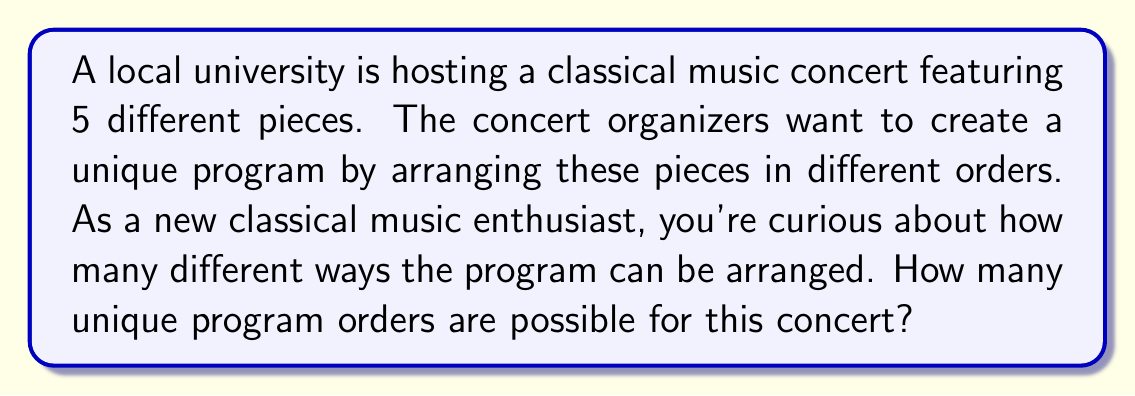Could you help me with this problem? To solve this problem, we need to use the concept of permutations. A permutation is an arrangement of objects where order matters.

In this case:
1. We have 5 distinct pieces of music.
2. We need to arrange all 5 pieces (no pieces are left out).
3. The order of the pieces matters (changing the order creates a new program).

This scenario is a perfect example of a permutation without repetition.

The formula for permutations without repetition is:

$$P(n) = n!$$

Where $n$ is the number of distinct objects (in this case, music pieces).

For our problem:
$$P(5) = 5!$$

Let's calculate this step-by-step:

$$\begin{align}
5! &= 5 \times 4 \times 3 \times 2 \times 1 \\
&= 120
\end{align}$$

Therefore, there are 120 unique ways to arrange the 5 pieces of music for the concert program.

This large number of possibilities demonstrates why each classical music concert can feel unique, even when featuring the same pieces. As a new enthusiast, you might appreciate how the order of pieces can affect the overall experience and emotional journey of the concert.
Answer: 120 unique program orders 